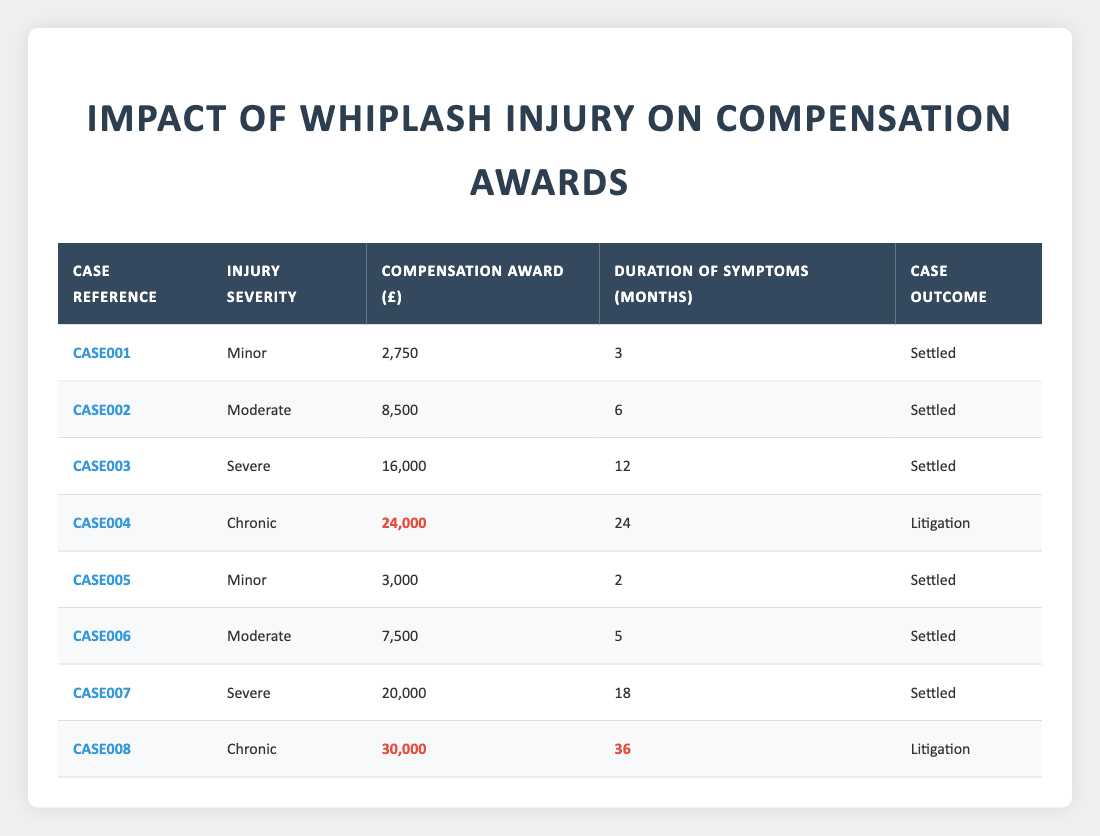What is the highest compensation award for a whiplash injury? The highest compensation award is found in CASE008 with a total of 30,000.
Answer: 30,000 Which case took the longest for symptoms to resolve? CASE008 has the longest duration of symptoms, showing 36 months.
Answer: 36 months How much compensation was awarded for moderate injuries? For moderate injuries, the awards are in CASE002 (8,500) and CASE006 (7,500). Adding these gives 8,500 + 7,500 = 16,000.
Answer: 16,000 How many cases were settled, and how many went to litigation? There are 6 cases that were settled (CASE001, CASE002, CASE003, CASE005, CASE006, CASE007) and 2 cases that went to litigation (CASE004, CASE008).
Answer: 6 settled, 2 litigation What is the total compensation awarded to all cases categorized as chronic injuries? The compensation for chronic injuries is 24,000 (CASE004) and 30,000 (CASE008). Adding these up gives 24,000 + 30,000 = 54,000.
Answer: 54,000 Is it true that all severe injuries resulted in settled cases? No, this is false because CASE007 is a severe injury that was settled, while CASE003 was also severe but settled, and the table does not indicate any severe injury going to litigation.
Answer: False What is the average compensation award for minor injuries? The compensation for minor injuries in CASE001 is 2,750, and in CASE005 it is 3,000. Their total is 2,750 + 3,000 = 5,750. Dividing by 2 cases gives an average of 5,750 / 2 = 2,875.
Answer: 2,875 If a case is marked as litigation, what can be said about its compensation award? The compensation awards for cases marked as litigation (CASE004 and CASE008) are both higher than the maximum for settled cases, showing amounts of 24,000 and 30,000, indicating litigation often involves higher claims.
Answer: Higher than settled cases What is the difference in compensation between the worst and best cases? The worst case (CASE001) received 2,750, while the best case (CASE008) received 30,000. The difference is calculated by 30,000 - 2,750 = 27,250.
Answer: 27,250 Which injury severity had the most consistent compensation values? The minor injuries had the lowest compensation amounts, with only two values (2,750 and 3,000) and their values are close together compared to others with higher variability.
Answer: Minor injuries 